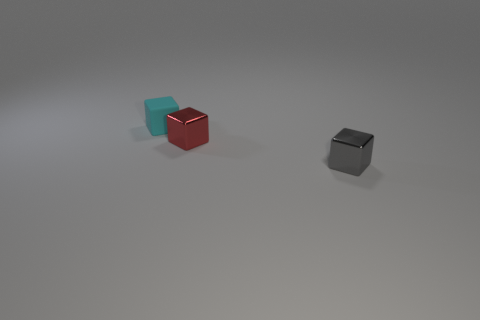Subtract all tiny matte cubes. How many cubes are left? 2 Subtract all gray cubes. How many cubes are left? 2 Add 2 red shiny things. How many objects exist? 5 Add 1 large purple rubber things. How many large purple rubber things exist? 1 Subtract 0 gray spheres. How many objects are left? 3 Subtract all red cubes. Subtract all yellow cylinders. How many cubes are left? 2 Subtract all gray cylinders. How many gray blocks are left? 1 Subtract all tiny gray metallic balls. Subtract all small cyan cubes. How many objects are left? 2 Add 3 red blocks. How many red blocks are left? 4 